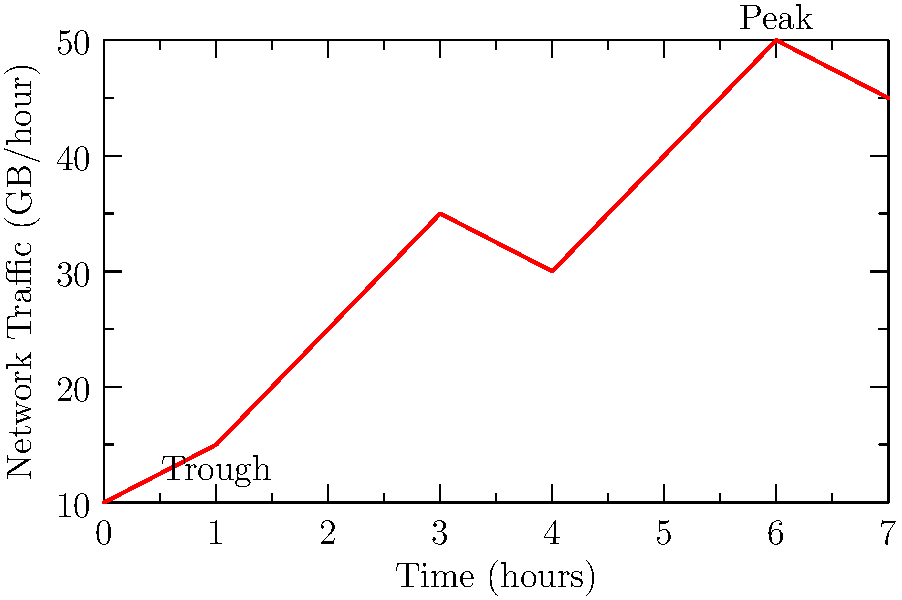In this network traffic analysis graph, which represents data from a champion's memoir launch event, what is the difference in GB/hour between the peak and trough of network activity? To find the difference between the peak and trough of network activity, we need to:

1. Identify the peak: The highest point on the graph is at 6 hours, reaching 50 GB/hour.
2. Identify the trough: The lowest point on the graph is at 1 hour, showing 15 GB/hour.
3. Calculate the difference:
   $50 \text{ GB/hour} - 15 \text{ GB/hour} = 35 \text{ GB/hour}$

This significant difference likely represents the surge in traffic when the champion's memoir became available online, followed by a period of lower activity as readers began to engage with the content.
Answer: 35 GB/hour 